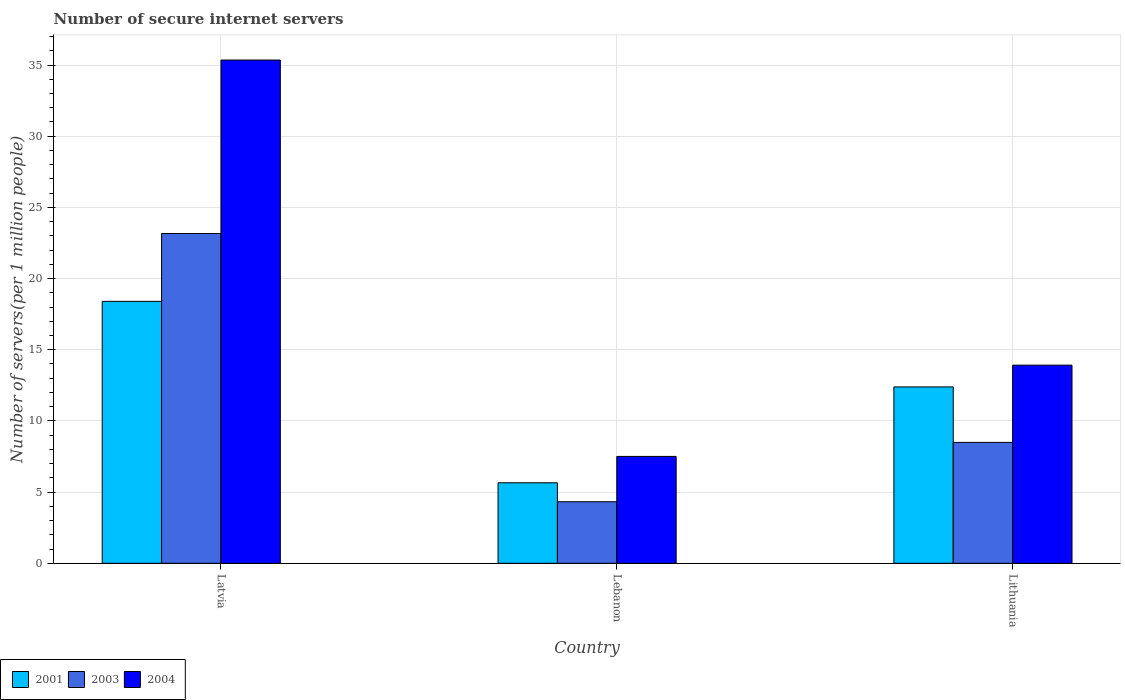How many different coloured bars are there?
Offer a very short reply. 3. How many groups of bars are there?
Make the answer very short. 3. Are the number of bars per tick equal to the number of legend labels?
Give a very brief answer. Yes. Are the number of bars on each tick of the X-axis equal?
Provide a succinct answer. Yes. How many bars are there on the 2nd tick from the left?
Give a very brief answer. 3. What is the label of the 1st group of bars from the left?
Offer a terse response. Latvia. In how many cases, is the number of bars for a given country not equal to the number of legend labels?
Provide a short and direct response. 0. What is the number of secure internet servers in 2004 in Latvia?
Give a very brief answer. 35.35. Across all countries, what is the maximum number of secure internet servers in 2004?
Keep it short and to the point. 35.35. Across all countries, what is the minimum number of secure internet servers in 2004?
Your answer should be compact. 7.51. In which country was the number of secure internet servers in 2004 maximum?
Keep it short and to the point. Latvia. In which country was the number of secure internet servers in 2004 minimum?
Your response must be concise. Lebanon. What is the total number of secure internet servers in 2001 in the graph?
Give a very brief answer. 36.44. What is the difference between the number of secure internet servers in 2004 in Lebanon and that in Lithuania?
Provide a short and direct response. -6.41. What is the difference between the number of secure internet servers in 2004 in Latvia and the number of secure internet servers in 2001 in Lithuania?
Provide a short and direct response. 22.96. What is the average number of secure internet servers in 2003 per country?
Your response must be concise. 11.99. What is the difference between the number of secure internet servers of/in 2004 and number of secure internet servers of/in 2001 in Latvia?
Provide a short and direct response. 16.95. What is the ratio of the number of secure internet servers in 2004 in Lebanon to that in Lithuania?
Ensure brevity in your answer.  0.54. Is the number of secure internet servers in 2001 in Latvia less than that in Lebanon?
Your answer should be compact. No. What is the difference between the highest and the second highest number of secure internet servers in 2003?
Ensure brevity in your answer.  4.17. What is the difference between the highest and the lowest number of secure internet servers in 2004?
Your response must be concise. 27.84. In how many countries, is the number of secure internet servers in 2001 greater than the average number of secure internet servers in 2001 taken over all countries?
Make the answer very short. 2. How many countries are there in the graph?
Keep it short and to the point. 3. Does the graph contain any zero values?
Give a very brief answer. No. Does the graph contain grids?
Your answer should be compact. Yes. How many legend labels are there?
Offer a terse response. 3. What is the title of the graph?
Offer a very short reply. Number of secure internet servers. What is the label or title of the X-axis?
Your answer should be compact. Country. What is the label or title of the Y-axis?
Ensure brevity in your answer.  Number of servers(per 1 million people). What is the Number of servers(per 1 million people) in 2001 in Latvia?
Offer a terse response. 18.4. What is the Number of servers(per 1 million people) of 2003 in Latvia?
Ensure brevity in your answer.  23.16. What is the Number of servers(per 1 million people) of 2004 in Latvia?
Keep it short and to the point. 35.35. What is the Number of servers(per 1 million people) in 2001 in Lebanon?
Give a very brief answer. 5.65. What is the Number of servers(per 1 million people) of 2003 in Lebanon?
Your answer should be very brief. 4.32. What is the Number of servers(per 1 million people) of 2004 in Lebanon?
Your response must be concise. 7.51. What is the Number of servers(per 1 million people) in 2001 in Lithuania?
Your response must be concise. 12.39. What is the Number of servers(per 1 million people) in 2003 in Lithuania?
Give a very brief answer. 8.49. What is the Number of servers(per 1 million people) of 2004 in Lithuania?
Your response must be concise. 13.92. Across all countries, what is the maximum Number of servers(per 1 million people) of 2001?
Provide a short and direct response. 18.4. Across all countries, what is the maximum Number of servers(per 1 million people) in 2003?
Keep it short and to the point. 23.16. Across all countries, what is the maximum Number of servers(per 1 million people) of 2004?
Offer a very short reply. 35.35. Across all countries, what is the minimum Number of servers(per 1 million people) in 2001?
Give a very brief answer. 5.65. Across all countries, what is the minimum Number of servers(per 1 million people) of 2003?
Offer a terse response. 4.32. Across all countries, what is the minimum Number of servers(per 1 million people) in 2004?
Provide a short and direct response. 7.51. What is the total Number of servers(per 1 million people) of 2001 in the graph?
Your answer should be very brief. 36.44. What is the total Number of servers(per 1 million people) in 2003 in the graph?
Your response must be concise. 35.98. What is the total Number of servers(per 1 million people) of 2004 in the graph?
Ensure brevity in your answer.  56.77. What is the difference between the Number of servers(per 1 million people) in 2001 in Latvia and that in Lebanon?
Ensure brevity in your answer.  12.74. What is the difference between the Number of servers(per 1 million people) of 2003 in Latvia and that in Lebanon?
Keep it short and to the point. 18.84. What is the difference between the Number of servers(per 1 million people) of 2004 in Latvia and that in Lebanon?
Offer a very short reply. 27.84. What is the difference between the Number of servers(per 1 million people) in 2001 in Latvia and that in Lithuania?
Offer a very short reply. 6.01. What is the difference between the Number of servers(per 1 million people) of 2003 in Latvia and that in Lithuania?
Provide a short and direct response. 14.67. What is the difference between the Number of servers(per 1 million people) in 2004 in Latvia and that in Lithuania?
Give a very brief answer. 21.43. What is the difference between the Number of servers(per 1 million people) of 2001 in Lebanon and that in Lithuania?
Make the answer very short. -6.73. What is the difference between the Number of servers(per 1 million people) of 2003 in Lebanon and that in Lithuania?
Keep it short and to the point. -4.17. What is the difference between the Number of servers(per 1 million people) of 2004 in Lebanon and that in Lithuania?
Ensure brevity in your answer.  -6.41. What is the difference between the Number of servers(per 1 million people) of 2001 in Latvia and the Number of servers(per 1 million people) of 2003 in Lebanon?
Your response must be concise. 14.08. What is the difference between the Number of servers(per 1 million people) in 2001 in Latvia and the Number of servers(per 1 million people) in 2004 in Lebanon?
Make the answer very short. 10.89. What is the difference between the Number of servers(per 1 million people) in 2003 in Latvia and the Number of servers(per 1 million people) in 2004 in Lebanon?
Your response must be concise. 15.66. What is the difference between the Number of servers(per 1 million people) of 2001 in Latvia and the Number of servers(per 1 million people) of 2003 in Lithuania?
Offer a terse response. 9.91. What is the difference between the Number of servers(per 1 million people) of 2001 in Latvia and the Number of servers(per 1 million people) of 2004 in Lithuania?
Provide a short and direct response. 4.48. What is the difference between the Number of servers(per 1 million people) in 2003 in Latvia and the Number of servers(per 1 million people) in 2004 in Lithuania?
Provide a short and direct response. 9.25. What is the difference between the Number of servers(per 1 million people) in 2001 in Lebanon and the Number of servers(per 1 million people) in 2003 in Lithuania?
Offer a very short reply. -2.84. What is the difference between the Number of servers(per 1 million people) in 2001 in Lebanon and the Number of servers(per 1 million people) in 2004 in Lithuania?
Give a very brief answer. -8.26. What is the difference between the Number of servers(per 1 million people) of 2003 in Lebanon and the Number of servers(per 1 million people) of 2004 in Lithuania?
Offer a terse response. -9.59. What is the average Number of servers(per 1 million people) in 2001 per country?
Make the answer very short. 12.15. What is the average Number of servers(per 1 million people) in 2003 per country?
Ensure brevity in your answer.  11.99. What is the average Number of servers(per 1 million people) in 2004 per country?
Keep it short and to the point. 18.92. What is the difference between the Number of servers(per 1 million people) in 2001 and Number of servers(per 1 million people) in 2003 in Latvia?
Provide a short and direct response. -4.77. What is the difference between the Number of servers(per 1 million people) in 2001 and Number of servers(per 1 million people) in 2004 in Latvia?
Your answer should be compact. -16.95. What is the difference between the Number of servers(per 1 million people) of 2003 and Number of servers(per 1 million people) of 2004 in Latvia?
Provide a succinct answer. -12.18. What is the difference between the Number of servers(per 1 million people) in 2001 and Number of servers(per 1 million people) in 2003 in Lebanon?
Ensure brevity in your answer.  1.33. What is the difference between the Number of servers(per 1 million people) in 2001 and Number of servers(per 1 million people) in 2004 in Lebanon?
Make the answer very short. -1.85. What is the difference between the Number of servers(per 1 million people) of 2003 and Number of servers(per 1 million people) of 2004 in Lebanon?
Your answer should be very brief. -3.18. What is the difference between the Number of servers(per 1 million people) in 2001 and Number of servers(per 1 million people) in 2003 in Lithuania?
Your response must be concise. 3.9. What is the difference between the Number of servers(per 1 million people) in 2001 and Number of servers(per 1 million people) in 2004 in Lithuania?
Offer a terse response. -1.53. What is the difference between the Number of servers(per 1 million people) of 2003 and Number of servers(per 1 million people) of 2004 in Lithuania?
Make the answer very short. -5.43. What is the ratio of the Number of servers(per 1 million people) of 2001 in Latvia to that in Lebanon?
Provide a short and direct response. 3.25. What is the ratio of the Number of servers(per 1 million people) of 2003 in Latvia to that in Lebanon?
Your answer should be very brief. 5.36. What is the ratio of the Number of servers(per 1 million people) of 2004 in Latvia to that in Lebanon?
Ensure brevity in your answer.  4.71. What is the ratio of the Number of servers(per 1 million people) of 2001 in Latvia to that in Lithuania?
Offer a very short reply. 1.49. What is the ratio of the Number of servers(per 1 million people) in 2003 in Latvia to that in Lithuania?
Provide a short and direct response. 2.73. What is the ratio of the Number of servers(per 1 million people) in 2004 in Latvia to that in Lithuania?
Ensure brevity in your answer.  2.54. What is the ratio of the Number of servers(per 1 million people) in 2001 in Lebanon to that in Lithuania?
Your response must be concise. 0.46. What is the ratio of the Number of servers(per 1 million people) in 2003 in Lebanon to that in Lithuania?
Provide a short and direct response. 0.51. What is the ratio of the Number of servers(per 1 million people) in 2004 in Lebanon to that in Lithuania?
Your response must be concise. 0.54. What is the difference between the highest and the second highest Number of servers(per 1 million people) in 2001?
Your response must be concise. 6.01. What is the difference between the highest and the second highest Number of servers(per 1 million people) in 2003?
Ensure brevity in your answer.  14.67. What is the difference between the highest and the second highest Number of servers(per 1 million people) of 2004?
Your response must be concise. 21.43. What is the difference between the highest and the lowest Number of servers(per 1 million people) in 2001?
Provide a short and direct response. 12.74. What is the difference between the highest and the lowest Number of servers(per 1 million people) of 2003?
Your response must be concise. 18.84. What is the difference between the highest and the lowest Number of servers(per 1 million people) of 2004?
Your answer should be very brief. 27.84. 